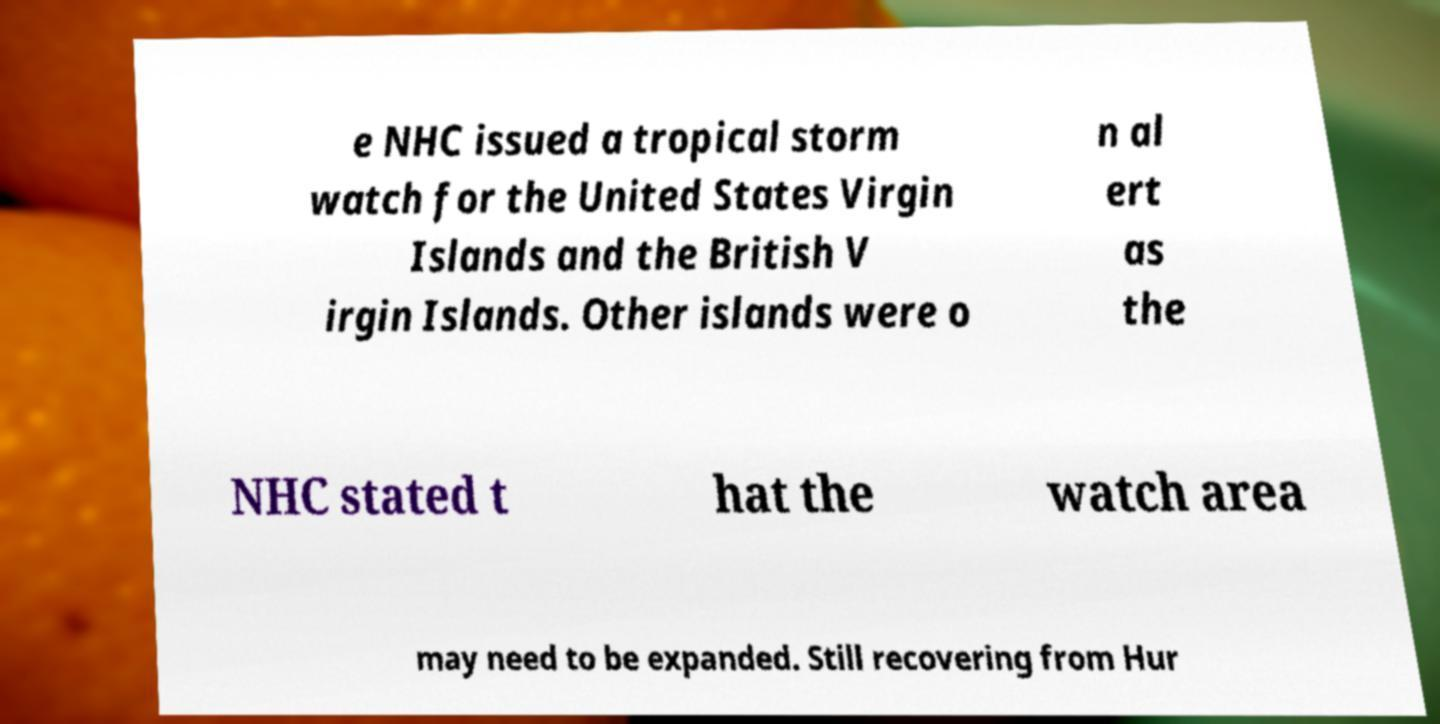Please identify and transcribe the text found in this image. e NHC issued a tropical storm watch for the United States Virgin Islands and the British V irgin Islands. Other islands were o n al ert as the NHC stated t hat the watch area may need to be expanded. Still recovering from Hur 